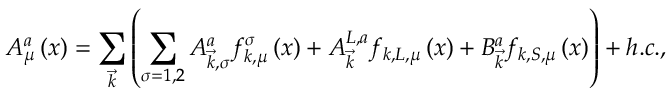Convert formula to latex. <formula><loc_0><loc_0><loc_500><loc_500>A _ { \mu } ^ { a } \left ( x \right ) = \sum _ { \vec { k } } \left ( \sum _ { \sigma = 1 , 2 } A _ { \vec { k } , \sigma } ^ { a } f _ { k , \mu } ^ { \sigma } \left ( x \right ) + A _ { \vec { k } } ^ { L , a } f _ { k , L , \mu } \left ( x \right ) + B _ { \vec { k } } ^ { a } f _ { k , S , \mu } \left ( x \right ) \right ) + h . c . ,</formula> 